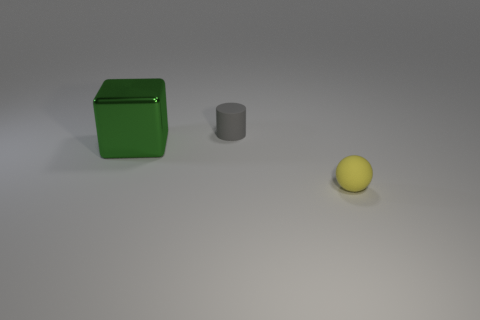Is there any other thing that has the same size as the metallic thing?
Provide a short and direct response. No. Are there any other things that are the same shape as the small yellow thing?
Offer a very short reply. No. Are there more balls than tiny matte objects?
Keep it short and to the point. No. Do the big block and the object that is on the right side of the gray cylinder have the same color?
Offer a terse response. No. What color is the thing that is right of the big green thing and behind the yellow sphere?
Your answer should be very brief. Gray. How many other things are made of the same material as the small gray object?
Provide a succinct answer. 1. Is the number of tiny yellow rubber objects less than the number of large gray metal blocks?
Offer a very short reply. No. Does the yellow object have the same material as the green cube that is in front of the gray matte cylinder?
Your answer should be compact. No. What is the shape of the small rubber object in front of the small cylinder?
Your response must be concise. Sphere. Is there anything else that is the same color as the metallic thing?
Provide a short and direct response. No. 